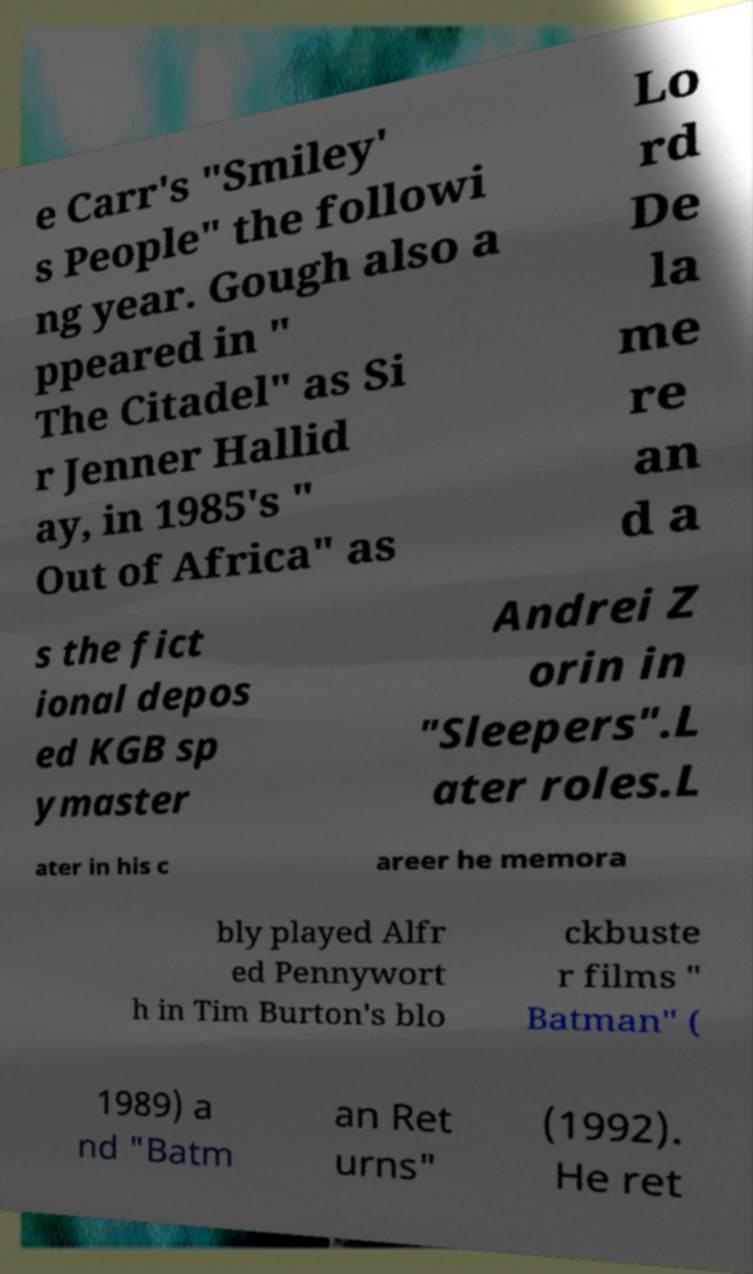Please identify and transcribe the text found in this image. e Carr's "Smiley' s People" the followi ng year. Gough also a ppeared in " The Citadel" as Si r Jenner Hallid ay, in 1985's " Out of Africa" as Lo rd De la me re an d a s the fict ional depos ed KGB sp ymaster Andrei Z orin in "Sleepers".L ater roles.L ater in his c areer he memora bly played Alfr ed Pennywort h in Tim Burton's blo ckbuste r films " Batman" ( 1989) a nd "Batm an Ret urns" (1992). He ret 